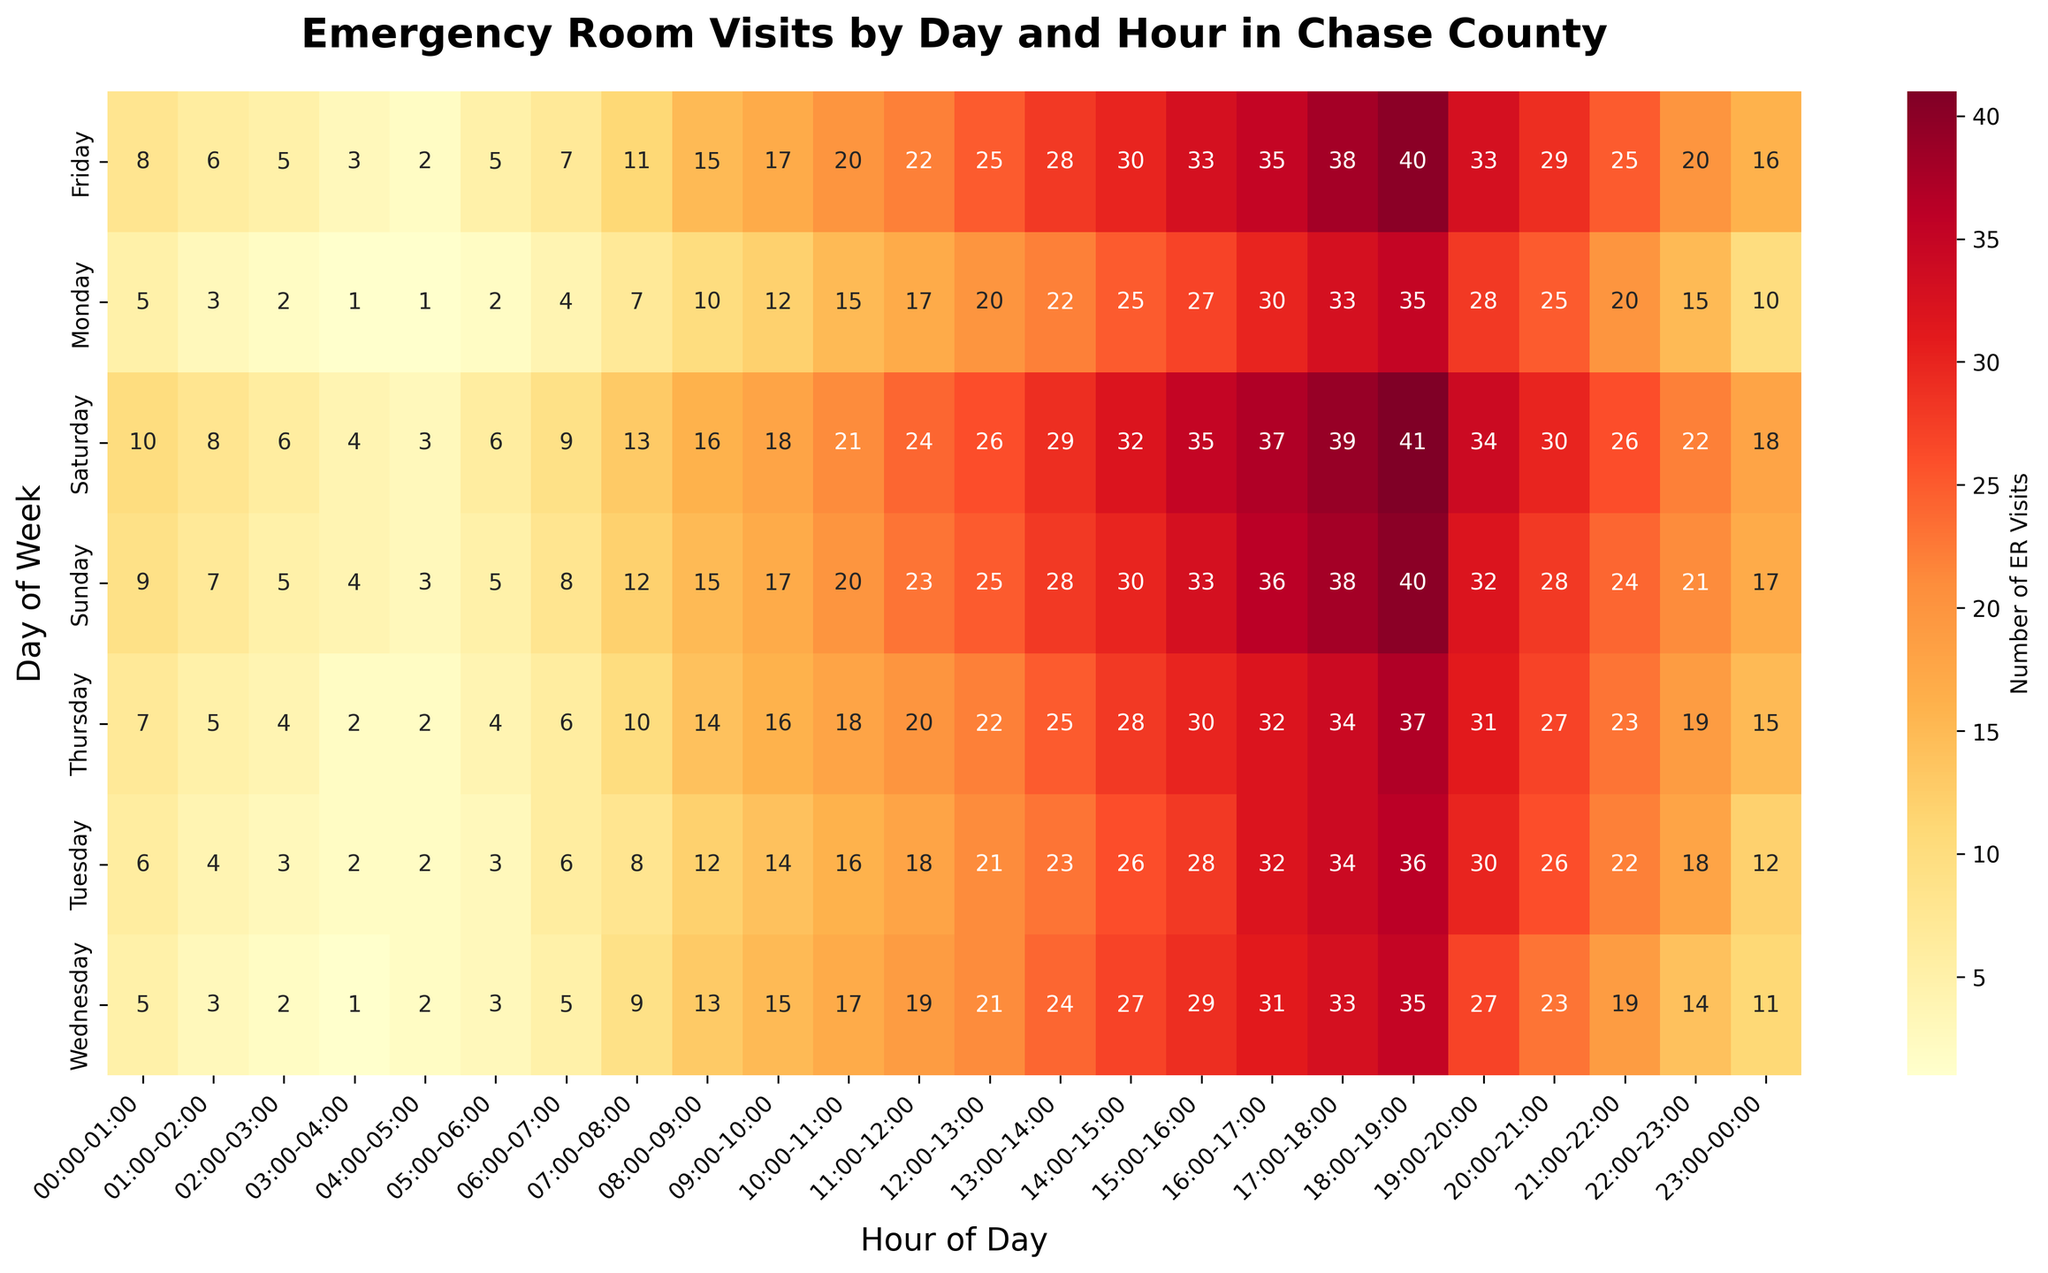Which day has the highest number of ER visits between 17:00 and 18:00? Check each row corresponding to 17:00-18:00 across all days. Saturday has the highest number with 39.
Answer: Saturday Which hour on Tuesday sees the most ER visits? Scan the row corresponding to Tuesday and identify the hour with the highest value. It is 18:00-19:00 with 36 visits.
Answer: 18:00-19:00 What is the total number of ER visits on Monday? Sum all the values in the row corresponding to Monday. The sum is 356.
Answer: 356 How do the ER visits on Friday from 16:00 to 17:00 compare to those on Sunday from 16:00 to 17:00? Compare the values in the respective cells. Friday (35) has fewer visits than Sunday (36).
Answer: Fewer Which day has the lowest ER visits during the early morning (00:00 to 01:00)? Scan the row corresponding to 00:00-01:00 across all days. Monday, Wednesday, and Thursday are tied with 5 visits each.
Answer: Monday, Wednesday, Thursday What is the average number of ER visits on Sunday from 20:00 to 22:00? Add the values for 20:00-21:00 (28) and 21:00-22:00 (24), then divide by 2. The average is (28+24)/2 = 26.
Answer: 26 Compare the number of ER visits on Wednesday at 10:00-11:00 with Thursday at the same time. Look at the values in the respective cells. Wednesday has 17 visits and Thursday has 18 visits, so Thursday has more.
Answer: Thursday Which period of the day shows the highest number of ER visits on all days? Identify the cell with the highest value across the entire heatmap. The cell corresponding to Friday at 18:00-19:00 has 40 visits.
Answer: Friday 18:00-19:00 What is the difference in ER visits between Monday 15:00-16:00 and Wednesday 15:00-16:00? Subtract the value for Wednesday (29) from Monday (27). The difference is 27-29 = -2.
Answer: -2 How do the ER visits on Saturday from 08:00 to 10:00 compare to those on Monday from 08:00 to 10:00? Sum the visits for Saturday (08:00 = 16, 09:00 = 18, total = 34) and Monday (08:00 = 10, 09:00 = 12, total = 22). Saturday has more visits than Monday.
Answer: Saturday has more 